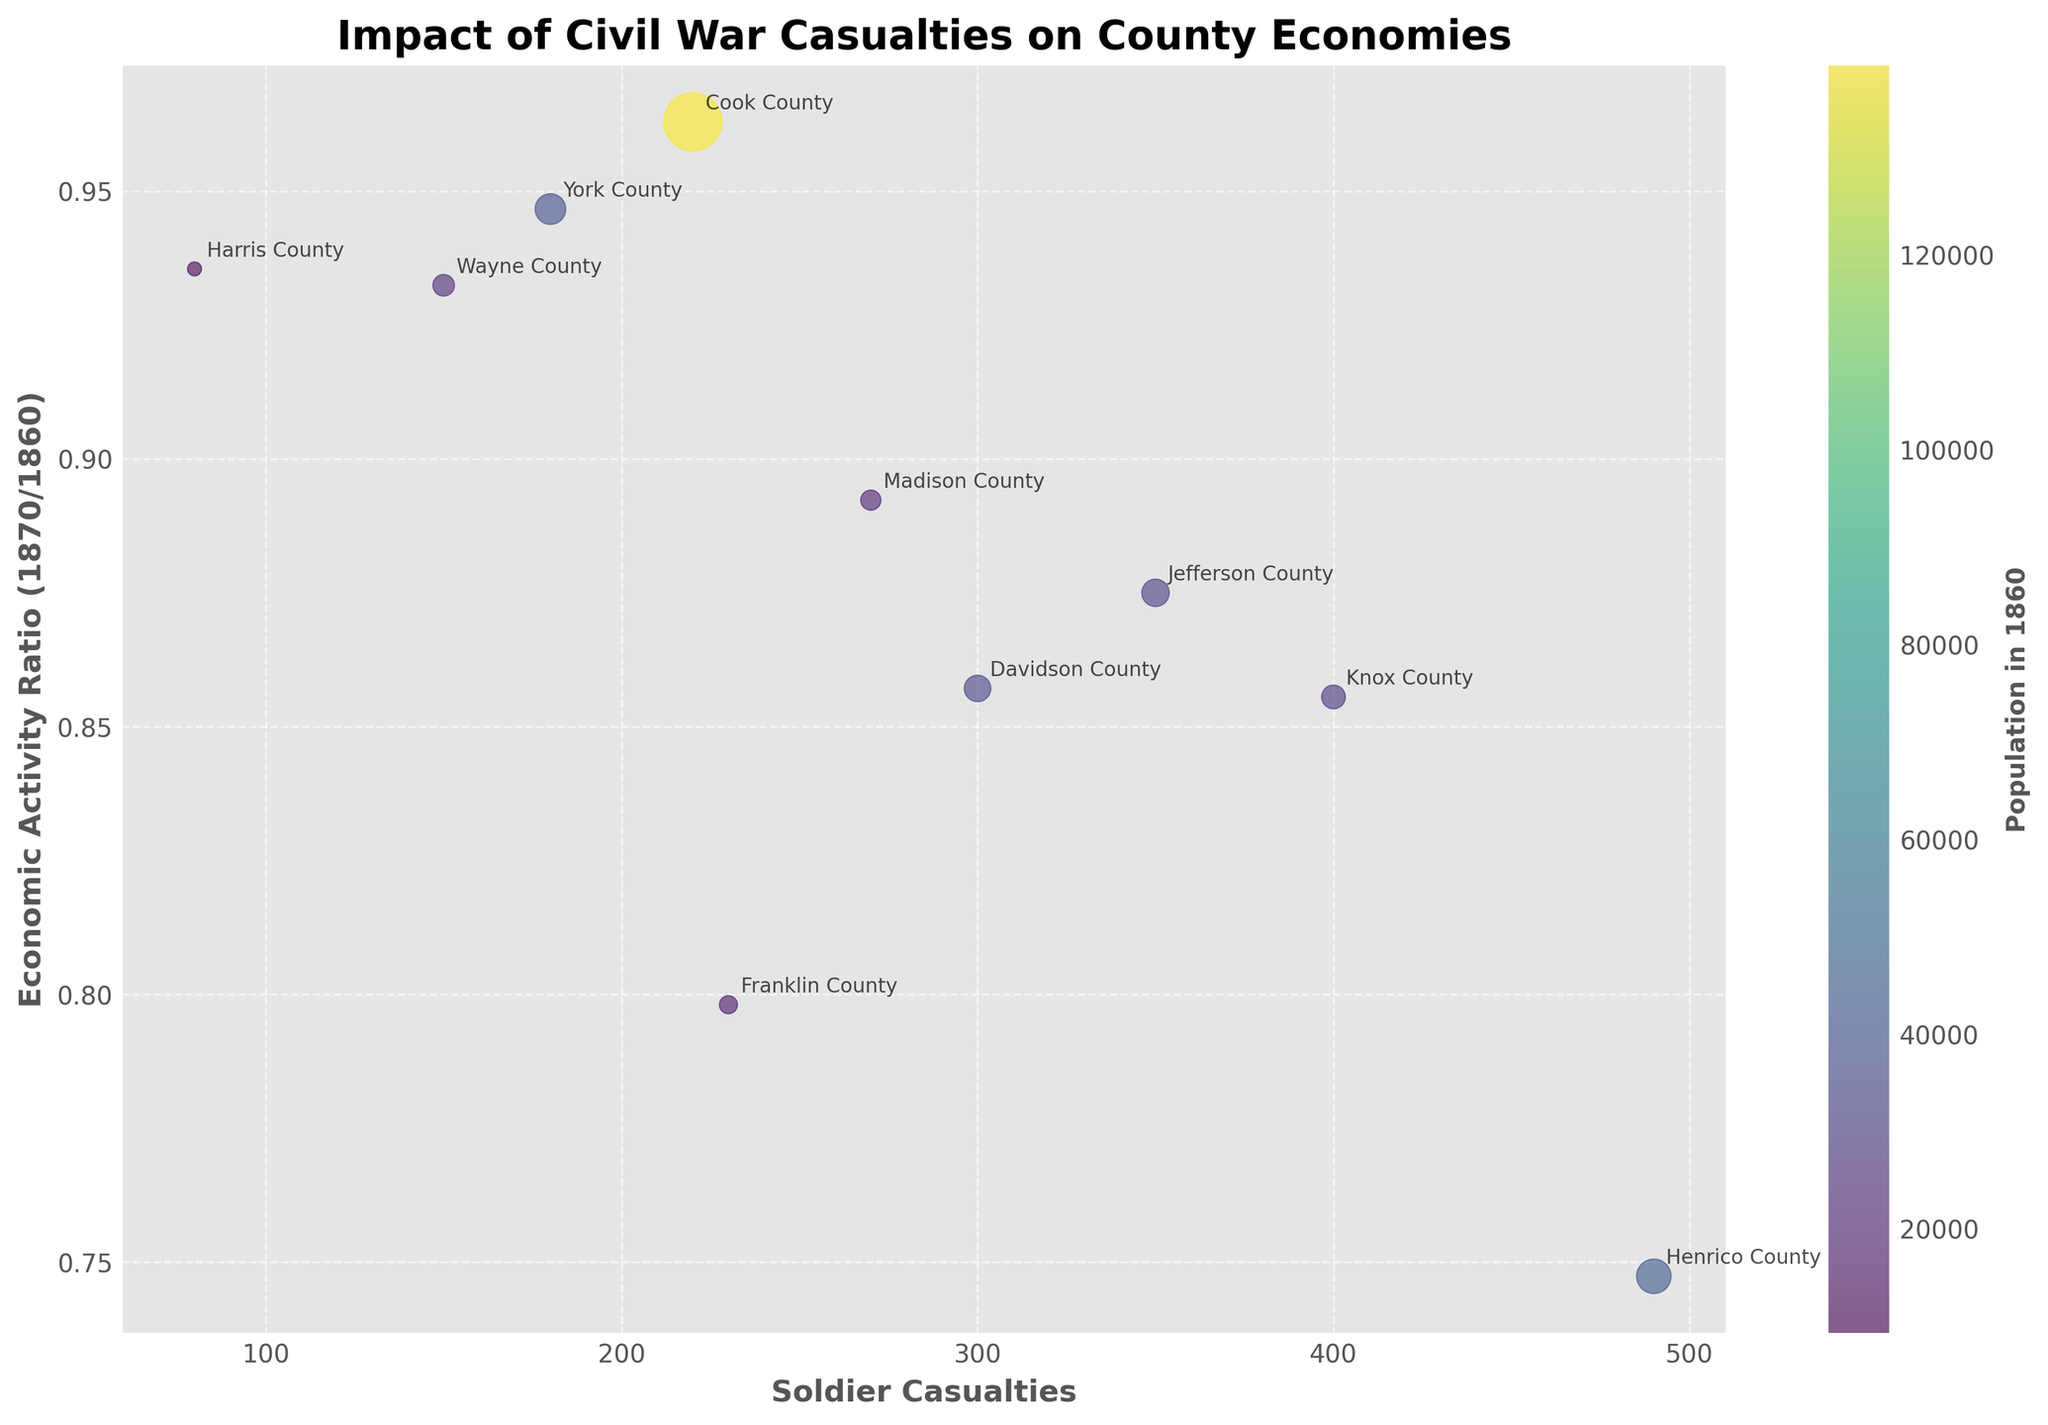How many counties are shown in the plot? The figure contains a separately labeled point for each county. By counting these points, including their labels, we can determine the number of counties.
Answer: 10 What is the title of the plot? The title of the plot is displayed at the top of the figure.
Answer: Impact of Civil War Casualties on County Economies Which county had the highest number of soldier casualties? By examining the horizontal axis (Soldier Casualties), we can identify the point farthest to the right, which corresponds to the county with the highest casualties.
Answer: Henrico County, Virginia Which county experienced the largest drop in economic activity ratio from 1860 to 1870? By looking for the lowest point on the vertical axis (Economic Activity Ratio), we can identify which county had the largest decrease.
Answer: Franklin County, Georgia What does the color in the plot represent? The color bar on the right side of the plot explains what the colors of the points represent.
Answer: Population in 1860 On average, how did soldier casualties affect economic activity ratios in the counties? To determine the general trend, examine whether most counties with higher casualties have economic activity ratios below or above 1.
Answer: Generally, higher casualties correlate with lower economic activity ratios Which county, with over 200 soldier casualties, maintained an economic activity ratio closest to 1? Focus on counties with more than 200 casualties and look for the point closest to the value of 1 on the vertical axis.
Answer: Cook County, Illinois How is the size of each point in the scatter plot determined? The size of the points varies and the legend or context may provide a clue. The code suggests that the point size is proportional to economic activity in 1860.
Answer: Economic Activity in 1860 Compare the economic impact between Jefferson County, Kentucky, and Davidson County, Tennessee. Which county had a smaller economic activity ratio in 1870? Locate both counties on the plot and compare their positions on the vertical axis. The county lower on the axis has the smaller ratio.
Answer: Jefferson County, Kentucky If we focus on counties with fewer than 200 soldier casualties, which one has the highest economic activity ratio in 1870? Examine the points left of the 200 mark on the horizontal axis (Soldier Casualties) and identify the highest point on the vertical axis (Economic Activity Ratio).
Answer: Harris County, Texas 